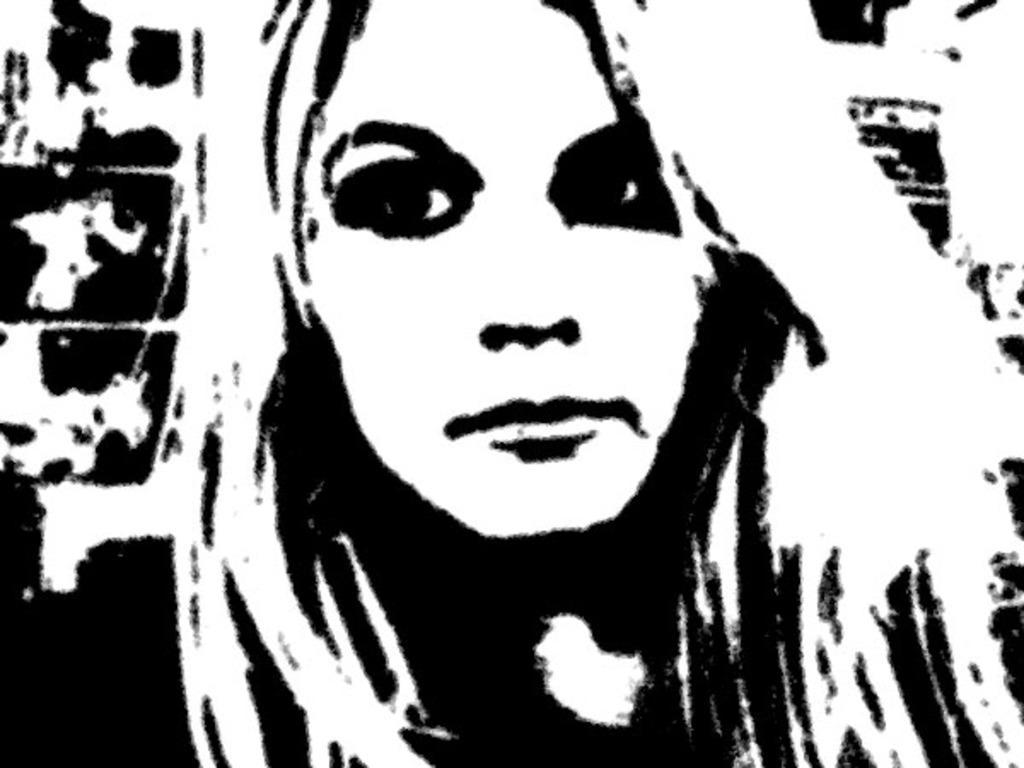Could you give a brief overview of what you see in this image? This looks like an edited black and white image. I can see the woman. 